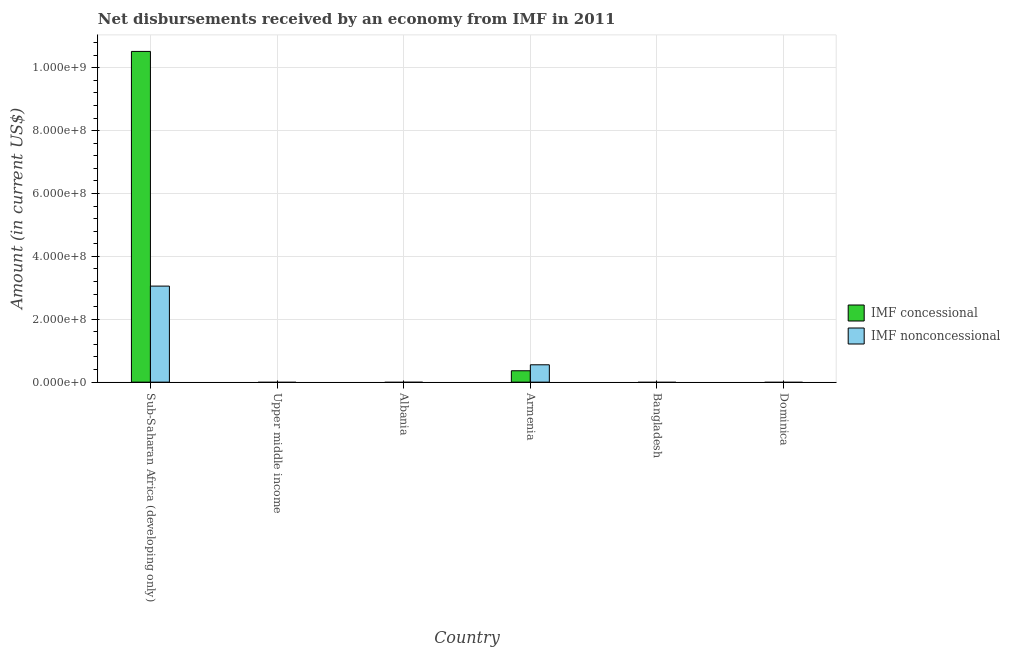Are the number of bars per tick equal to the number of legend labels?
Keep it short and to the point. No. How many bars are there on the 1st tick from the left?
Your response must be concise. 2. How many bars are there on the 3rd tick from the right?
Ensure brevity in your answer.  2. What is the label of the 3rd group of bars from the left?
Offer a very short reply. Albania. In how many cases, is the number of bars for a given country not equal to the number of legend labels?
Ensure brevity in your answer.  4. What is the net non concessional disbursements from imf in Sub-Saharan Africa (developing only)?
Offer a terse response. 3.05e+08. Across all countries, what is the maximum net concessional disbursements from imf?
Provide a succinct answer. 1.05e+09. In which country was the net non concessional disbursements from imf maximum?
Make the answer very short. Sub-Saharan Africa (developing only). What is the total net non concessional disbursements from imf in the graph?
Give a very brief answer. 3.61e+08. What is the difference between the net non concessional disbursements from imf in Armenia and that in Sub-Saharan Africa (developing only)?
Keep it short and to the point. -2.50e+08. What is the difference between the net concessional disbursements from imf in Sub-Saharan Africa (developing only) and the net non concessional disbursements from imf in Albania?
Your response must be concise. 1.05e+09. What is the average net non concessional disbursements from imf per country?
Offer a terse response. 6.01e+07. What is the difference between the net concessional disbursements from imf and net non concessional disbursements from imf in Sub-Saharan Africa (developing only)?
Provide a succinct answer. 7.46e+08. What is the difference between the highest and the lowest net non concessional disbursements from imf?
Ensure brevity in your answer.  3.05e+08. In how many countries, is the net concessional disbursements from imf greater than the average net concessional disbursements from imf taken over all countries?
Keep it short and to the point. 1. Is the sum of the net concessional disbursements from imf in Armenia and Sub-Saharan Africa (developing only) greater than the maximum net non concessional disbursements from imf across all countries?
Your response must be concise. Yes. Are all the bars in the graph horizontal?
Make the answer very short. No. What is the difference between two consecutive major ticks on the Y-axis?
Offer a very short reply. 2.00e+08. Does the graph contain any zero values?
Your answer should be compact. Yes. How many legend labels are there?
Your answer should be compact. 2. What is the title of the graph?
Make the answer very short. Net disbursements received by an economy from IMF in 2011. What is the label or title of the Y-axis?
Ensure brevity in your answer.  Amount (in current US$). What is the Amount (in current US$) of IMF concessional in Sub-Saharan Africa (developing only)?
Make the answer very short. 1.05e+09. What is the Amount (in current US$) in IMF nonconcessional in Sub-Saharan Africa (developing only)?
Offer a very short reply. 3.05e+08. What is the Amount (in current US$) of IMF concessional in Upper middle income?
Your answer should be very brief. 0. What is the Amount (in current US$) of IMF nonconcessional in Upper middle income?
Ensure brevity in your answer.  0. What is the Amount (in current US$) in IMF concessional in Albania?
Keep it short and to the point. 0. What is the Amount (in current US$) of IMF nonconcessional in Albania?
Offer a terse response. 0. What is the Amount (in current US$) of IMF concessional in Armenia?
Provide a short and direct response. 3.62e+07. What is the Amount (in current US$) of IMF nonconcessional in Armenia?
Your response must be concise. 5.52e+07. What is the Amount (in current US$) of IMF concessional in Bangladesh?
Ensure brevity in your answer.  0. What is the Amount (in current US$) of IMF nonconcessional in Bangladesh?
Ensure brevity in your answer.  0. What is the Amount (in current US$) in IMF concessional in Dominica?
Your response must be concise. 0. What is the Amount (in current US$) in IMF nonconcessional in Dominica?
Ensure brevity in your answer.  0. Across all countries, what is the maximum Amount (in current US$) of IMF concessional?
Your answer should be compact. 1.05e+09. Across all countries, what is the maximum Amount (in current US$) in IMF nonconcessional?
Your answer should be very brief. 3.05e+08. Across all countries, what is the minimum Amount (in current US$) in IMF concessional?
Your answer should be compact. 0. Across all countries, what is the minimum Amount (in current US$) in IMF nonconcessional?
Your response must be concise. 0. What is the total Amount (in current US$) in IMF concessional in the graph?
Provide a succinct answer. 1.09e+09. What is the total Amount (in current US$) of IMF nonconcessional in the graph?
Your response must be concise. 3.61e+08. What is the difference between the Amount (in current US$) of IMF concessional in Sub-Saharan Africa (developing only) and that in Armenia?
Make the answer very short. 1.02e+09. What is the difference between the Amount (in current US$) of IMF nonconcessional in Sub-Saharan Africa (developing only) and that in Armenia?
Your response must be concise. 2.50e+08. What is the difference between the Amount (in current US$) in IMF concessional in Sub-Saharan Africa (developing only) and the Amount (in current US$) in IMF nonconcessional in Armenia?
Offer a very short reply. 9.97e+08. What is the average Amount (in current US$) of IMF concessional per country?
Your answer should be very brief. 1.81e+08. What is the average Amount (in current US$) of IMF nonconcessional per country?
Give a very brief answer. 6.01e+07. What is the difference between the Amount (in current US$) of IMF concessional and Amount (in current US$) of IMF nonconcessional in Sub-Saharan Africa (developing only)?
Offer a terse response. 7.46e+08. What is the difference between the Amount (in current US$) in IMF concessional and Amount (in current US$) in IMF nonconcessional in Armenia?
Make the answer very short. -1.90e+07. What is the ratio of the Amount (in current US$) in IMF concessional in Sub-Saharan Africa (developing only) to that in Armenia?
Keep it short and to the point. 29.05. What is the ratio of the Amount (in current US$) in IMF nonconcessional in Sub-Saharan Africa (developing only) to that in Armenia?
Keep it short and to the point. 5.53. What is the difference between the highest and the lowest Amount (in current US$) in IMF concessional?
Your answer should be very brief. 1.05e+09. What is the difference between the highest and the lowest Amount (in current US$) in IMF nonconcessional?
Your response must be concise. 3.05e+08. 